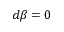<formula> <loc_0><loc_0><loc_500><loc_500>d \beta = 0</formula> 